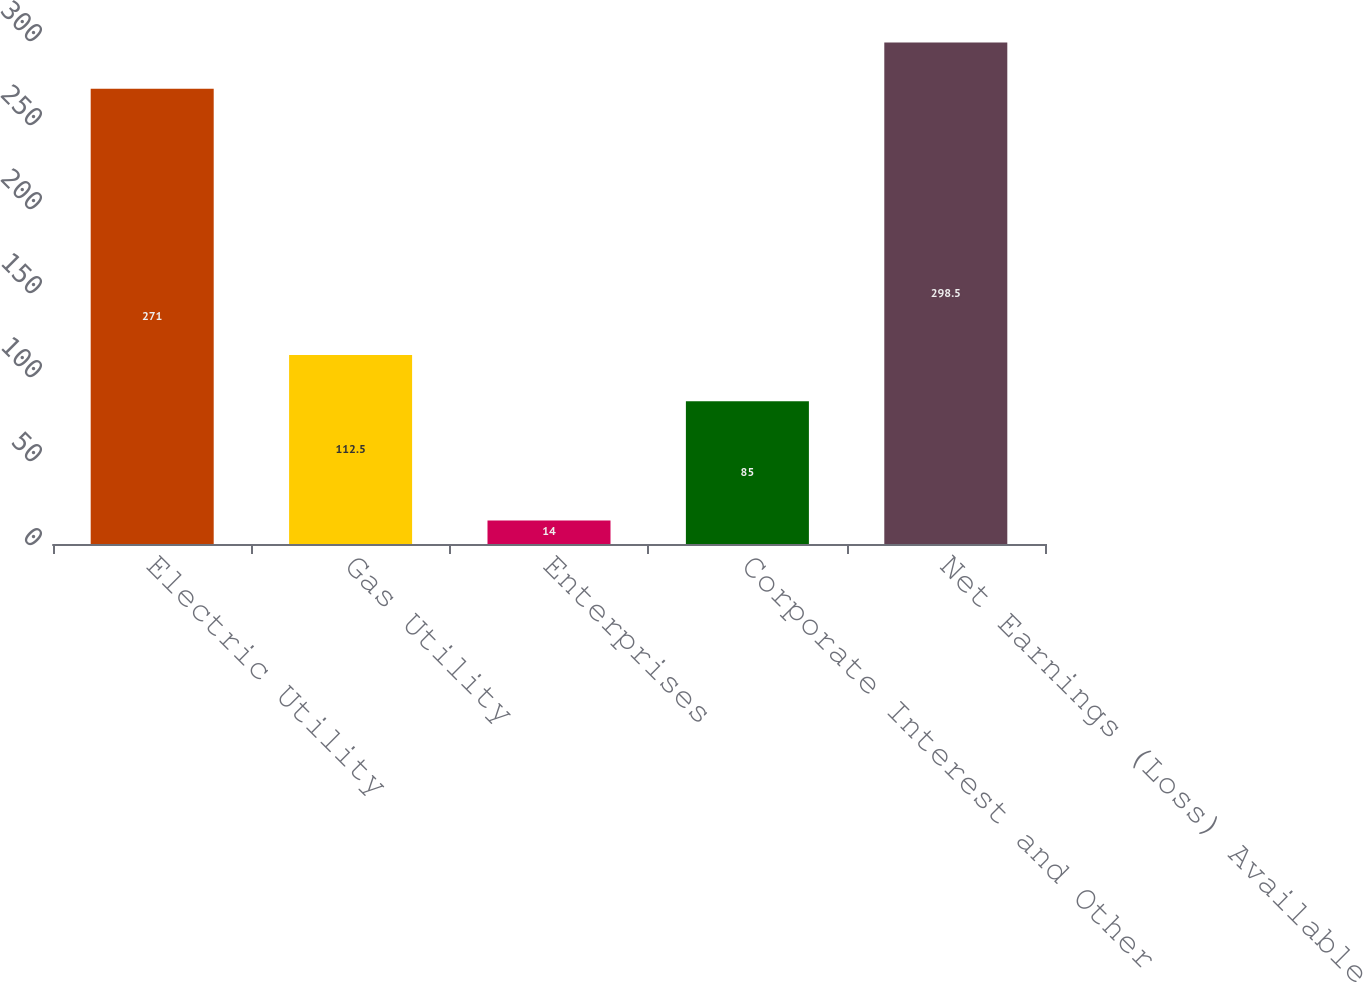Convert chart. <chart><loc_0><loc_0><loc_500><loc_500><bar_chart><fcel>Electric Utility<fcel>Gas Utility<fcel>Enterprises<fcel>Corporate Interest and Other<fcel>Net Earnings (Loss) Available<nl><fcel>271<fcel>112.5<fcel>14<fcel>85<fcel>298.5<nl></chart> 